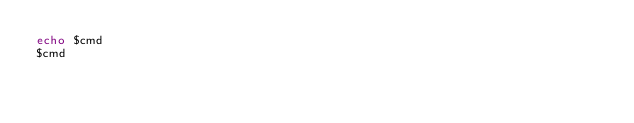Convert code to text. <code><loc_0><loc_0><loc_500><loc_500><_Bash_>echo $cmd
$cmd
</code> 